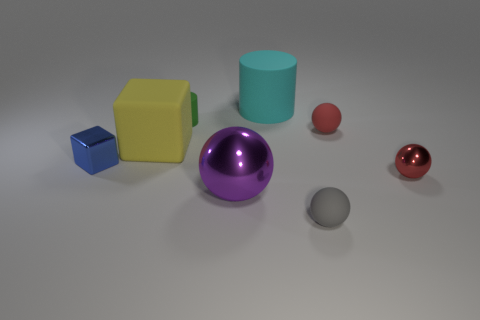What number of things are blue objects that are to the left of the tiny red metal thing or big matte cubes?
Keep it short and to the point. 2. Is the color of the large metal object the same as the tiny metal sphere?
Offer a terse response. No. How many other objects are the same shape as the blue thing?
Provide a short and direct response. 1. How many red things are either tiny cylinders or small rubber objects?
Offer a very short reply. 1. There is a block that is the same material as the tiny green object; what is its color?
Provide a succinct answer. Yellow. Are the large object that is on the right side of the large shiny ball and the large object to the left of the green rubber cylinder made of the same material?
Ensure brevity in your answer.  Yes. There is a matte ball that is the same color as the tiny metallic sphere; what is its size?
Offer a terse response. Small. There is a tiny red thing that is in front of the large yellow block; what is its material?
Ensure brevity in your answer.  Metal. There is a metallic object that is on the left side of the small rubber cylinder; is it the same shape as the big matte object that is to the left of the tiny green matte cylinder?
Ensure brevity in your answer.  Yes. There is another ball that is the same color as the tiny shiny ball; what material is it?
Make the answer very short. Rubber. 